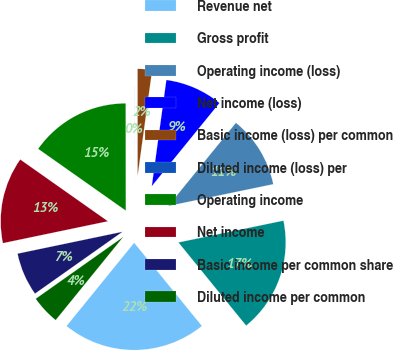Convert chart to OTSL. <chart><loc_0><loc_0><loc_500><loc_500><pie_chart><fcel>Revenue net<fcel>Gross profit<fcel>Operating income (loss)<fcel>Net income (loss)<fcel>Basic income (loss) per common<fcel>Diluted income (loss) per<fcel>Operating income<fcel>Net income<fcel>Basic income per common share<fcel>Diluted income per common<nl><fcel>21.73%<fcel>17.38%<fcel>10.87%<fcel>8.7%<fcel>2.18%<fcel>0.01%<fcel>15.21%<fcel>13.04%<fcel>6.52%<fcel>4.35%<nl></chart> 